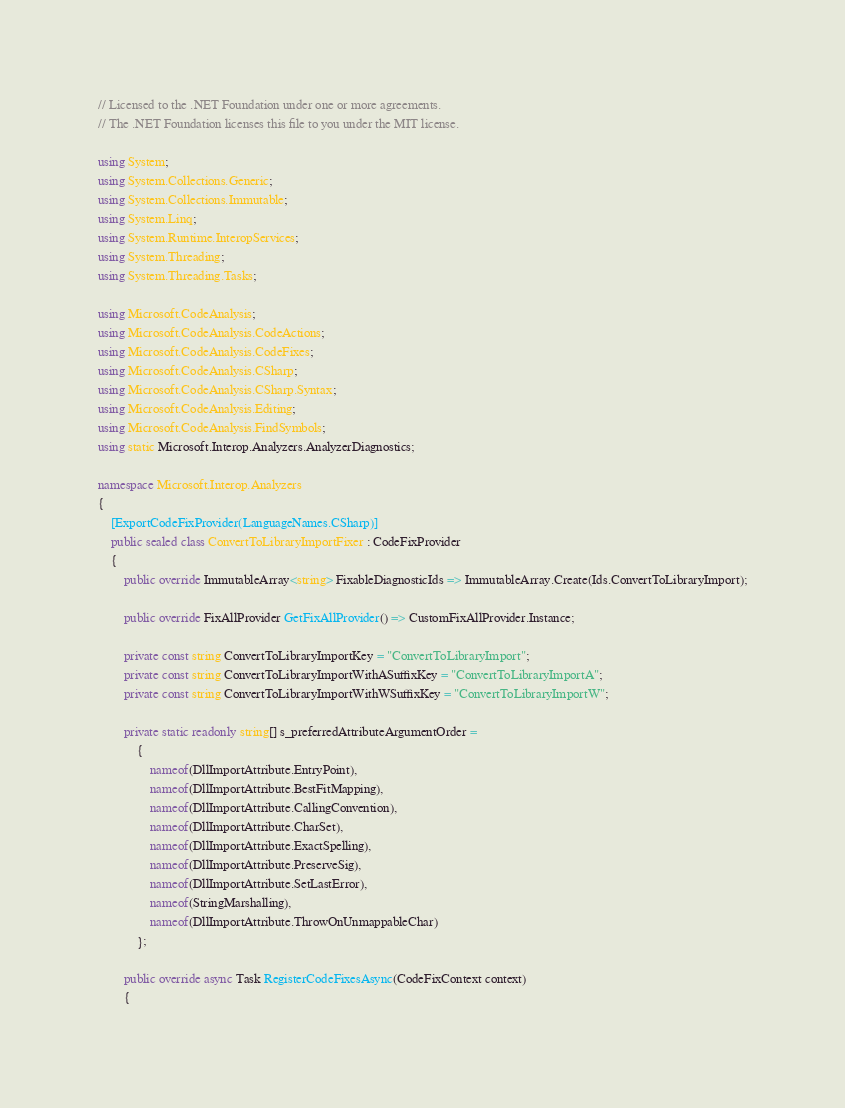<code> <loc_0><loc_0><loc_500><loc_500><_C#_>// Licensed to the .NET Foundation under one or more agreements.
// The .NET Foundation licenses this file to you under the MIT license.

using System;
using System.Collections.Generic;
using System.Collections.Immutable;
using System.Linq;
using System.Runtime.InteropServices;
using System.Threading;
using System.Threading.Tasks;

using Microsoft.CodeAnalysis;
using Microsoft.CodeAnalysis.CodeActions;
using Microsoft.CodeAnalysis.CodeFixes;
using Microsoft.CodeAnalysis.CSharp;
using Microsoft.CodeAnalysis.CSharp.Syntax;
using Microsoft.CodeAnalysis.Editing;
using Microsoft.CodeAnalysis.FindSymbols;
using static Microsoft.Interop.Analyzers.AnalyzerDiagnostics;

namespace Microsoft.Interop.Analyzers
{
    [ExportCodeFixProvider(LanguageNames.CSharp)]
    public sealed class ConvertToLibraryImportFixer : CodeFixProvider
    {
        public override ImmutableArray<string> FixableDiagnosticIds => ImmutableArray.Create(Ids.ConvertToLibraryImport);

        public override FixAllProvider GetFixAllProvider() => CustomFixAllProvider.Instance;

        private const string ConvertToLibraryImportKey = "ConvertToLibraryImport";
        private const string ConvertToLibraryImportWithASuffixKey = "ConvertToLibraryImportA";
        private const string ConvertToLibraryImportWithWSuffixKey = "ConvertToLibraryImportW";

        private static readonly string[] s_preferredAttributeArgumentOrder =
            {
                nameof(DllImportAttribute.EntryPoint),
                nameof(DllImportAttribute.BestFitMapping),
                nameof(DllImportAttribute.CallingConvention),
                nameof(DllImportAttribute.CharSet),
                nameof(DllImportAttribute.ExactSpelling),
                nameof(DllImportAttribute.PreserveSig),
                nameof(DllImportAttribute.SetLastError),
                nameof(StringMarshalling),
                nameof(DllImportAttribute.ThrowOnUnmappableChar)
            };

        public override async Task RegisterCodeFixesAsync(CodeFixContext context)
        {</code> 